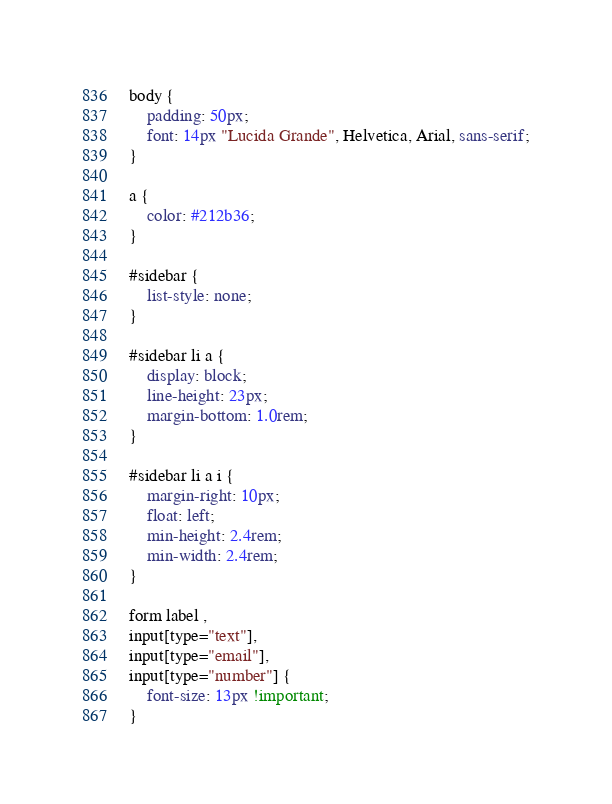<code> <loc_0><loc_0><loc_500><loc_500><_CSS_>body {
    padding: 50px;
    font: 14px "Lucida Grande", Helvetica, Arial, sans-serif;
}

a {
    color: #212b36;
}

#sidebar {
    list-style: none;
}

#sidebar li a {
    display: block;
    line-height: 23px;
    margin-bottom: 1.0rem;
}

#sidebar li a i {
    margin-right: 10px;
    float: left;
    min-height: 2.4rem;
    min-width: 2.4rem;
}

form label ,
input[type="text"],
input[type="email"],
input[type="number"] {
    font-size: 13px !important;
}
</code> 